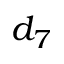<formula> <loc_0><loc_0><loc_500><loc_500>d _ { 7 }</formula> 